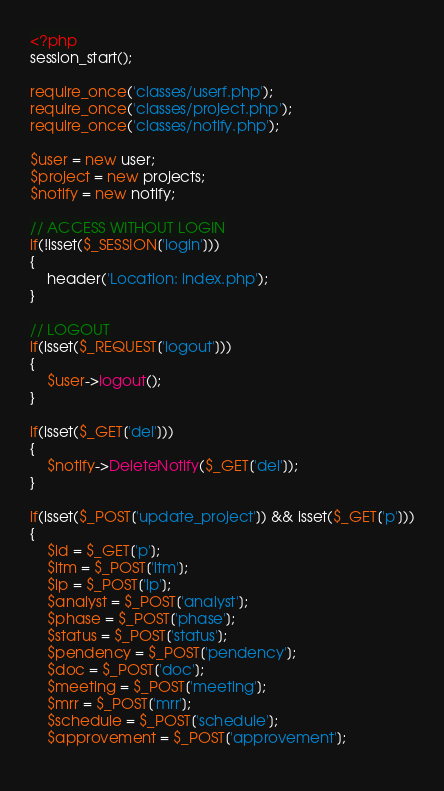<code> <loc_0><loc_0><loc_500><loc_500><_PHP_><?php
session_start();

require_once('classes/userf.php');
require_once('classes/project.php');
require_once('classes/notify.php');

$user = new user;
$project = new projects;
$notify = new notify;

// ACCESS WITHOUT LOGIN
if(!isset($_SESSION['login']))
{
	header('Location: index.php');
}

// LOGOUT
if(isset($_REQUEST['logout']))
{
	$user->logout();
}

if(isset($_GET['del']))
{
	$notify->DeleteNotify($_GET['del']);
}

if(isset($_POST['update_project']) && isset($_GET['p']))
{
	$id = $_GET['p'];
	$ltm = $_POST['ltm'];
	$lp = $_POST['lp'];
	$analyst = $_POST['analyst'];
	$phase = $_POST['phase'];
	$status = $_POST['status'];
	$pendency = $_POST['pendency'];
	$doc = $_POST['doc'];
	$meeting = $_POST['meeting'];
	$mrr = $_POST['mrr'];
	$schedule = $_POST['schedule'];
	$approvement = $_POST['approvement'];
	</code> 